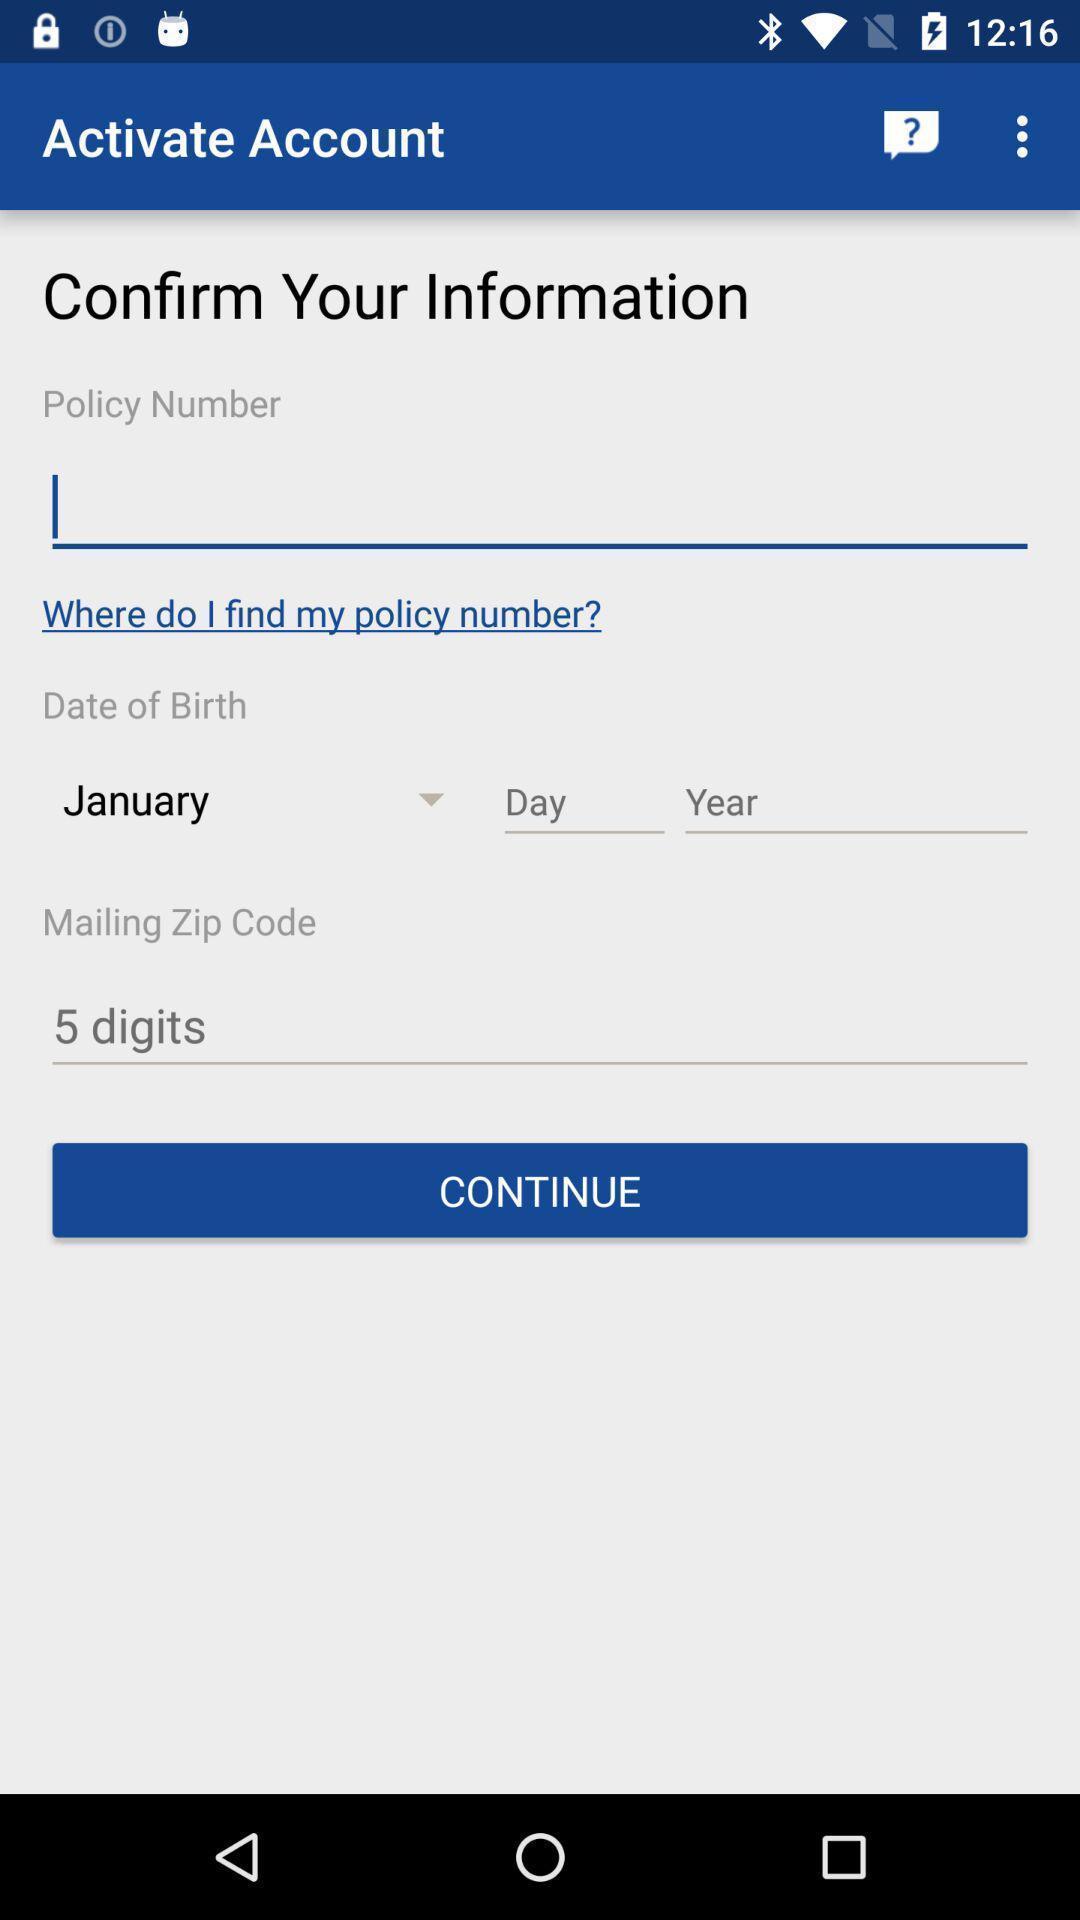Explain what's happening in this screen capture. Page showing account policy details. 